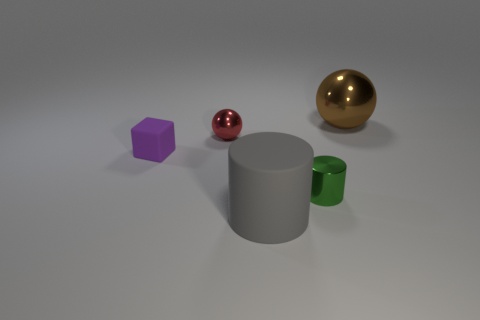There is a large matte object that is in front of the small red sphere; does it have the same color as the shiny cylinder?
Ensure brevity in your answer.  No. There is a big object that is to the left of the brown ball; does it have the same shape as the shiny thing left of the large gray rubber cylinder?
Your answer should be compact. No. What size is the metallic ball to the left of the green shiny cylinder?
Make the answer very short. Small. What size is the matte object to the right of the object that is left of the tiny red shiny sphere?
Your answer should be compact. Large. Are there more small yellow objects than red spheres?
Give a very brief answer. No. Is the number of red metallic spheres that are in front of the small red metal sphere greater than the number of cubes in front of the green metal cylinder?
Make the answer very short. No. There is a metallic object that is behind the purple matte cube and left of the big brown object; how big is it?
Provide a succinct answer. Small. How many metallic balls are the same size as the gray object?
Make the answer very short. 1. There is a small metallic object on the left side of the tiny green metallic object; does it have the same shape as the tiny green shiny object?
Your answer should be compact. No. Are there fewer purple things on the right side of the red object than cubes?
Your response must be concise. Yes. 